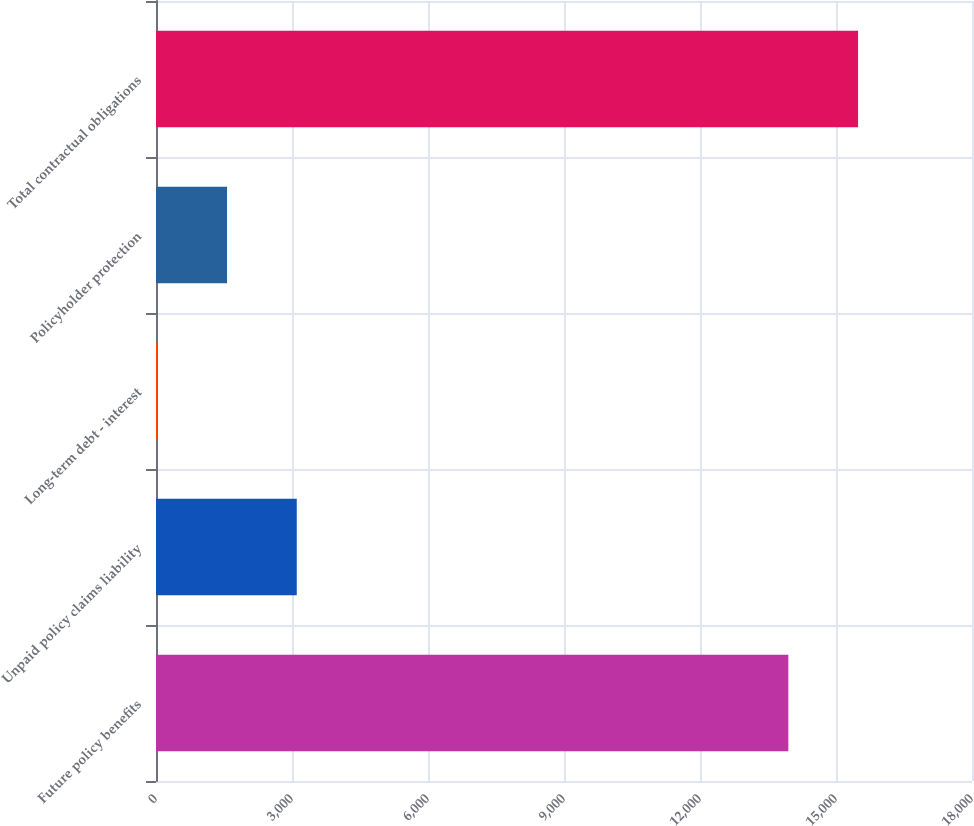Convert chart to OTSL. <chart><loc_0><loc_0><loc_500><loc_500><bar_chart><fcel>Future policy benefits<fcel>Unpaid policy claims liability<fcel>Long-term debt - interest<fcel>Policyholder protection<fcel>Total contractual obligations<nl><fcel>13949<fcel>3105<fcel>29<fcel>1567<fcel>15487<nl></chart> 